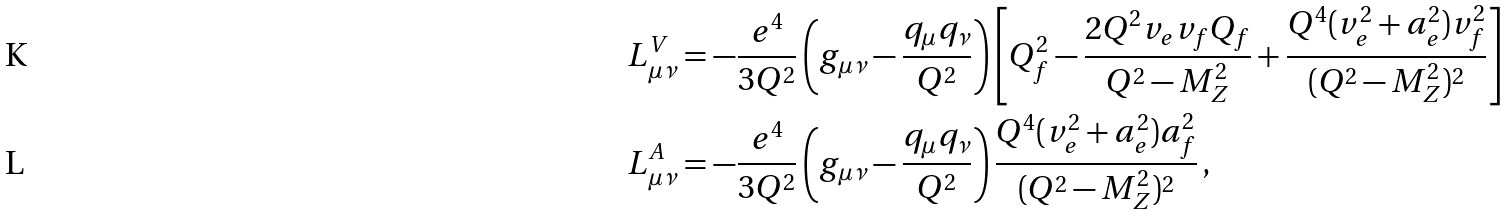Convert formula to latex. <formula><loc_0><loc_0><loc_500><loc_500>L ^ { V } _ { \mu \nu } & = - \frac { e ^ { 4 } } { 3 Q ^ { 2 } } \left ( g _ { \mu \nu } - \frac { q _ { \mu } q _ { \nu } } { Q ^ { 2 } } \right ) \left [ Q _ { f } ^ { 2 } - \frac { 2 Q ^ { 2 } v _ { e } v _ { f } Q _ { f } } { Q ^ { 2 } - M _ { Z } ^ { 2 } } + \frac { Q ^ { 4 } ( v _ { e } ^ { 2 } + a _ { e } ^ { 2 } ) v _ { f } ^ { 2 } } { ( Q ^ { 2 } - M _ { Z } ^ { 2 } ) ^ { 2 } } \right ] \\ L ^ { A } _ { \mu \nu } & = - \frac { e ^ { 4 } } { 3 Q ^ { 2 } } \left ( g _ { \mu \nu } - \frac { q _ { \mu } q _ { \nu } } { Q ^ { 2 } } \right ) \frac { Q ^ { 4 } ( v _ { e } ^ { 2 } + a _ { e } ^ { 2 } ) a _ { f } ^ { 2 } } { ( Q ^ { 2 } - M _ { Z } ^ { 2 } ) ^ { 2 } } \, ,</formula> 